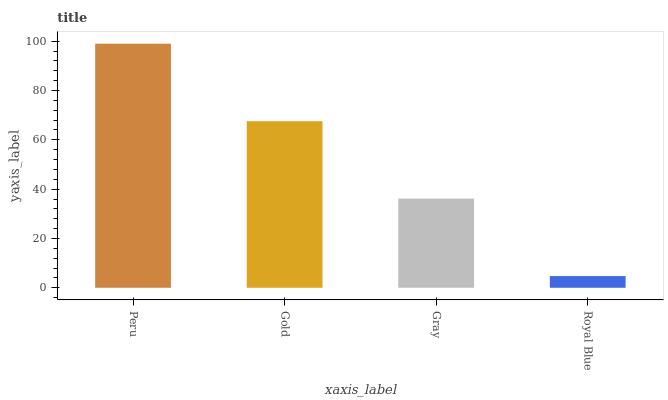Is Gold the minimum?
Answer yes or no. No. Is Gold the maximum?
Answer yes or no. No. Is Peru greater than Gold?
Answer yes or no. Yes. Is Gold less than Peru?
Answer yes or no. Yes. Is Gold greater than Peru?
Answer yes or no. No. Is Peru less than Gold?
Answer yes or no. No. Is Gold the high median?
Answer yes or no. Yes. Is Gray the low median?
Answer yes or no. Yes. Is Gray the high median?
Answer yes or no. No. Is Peru the low median?
Answer yes or no. No. 